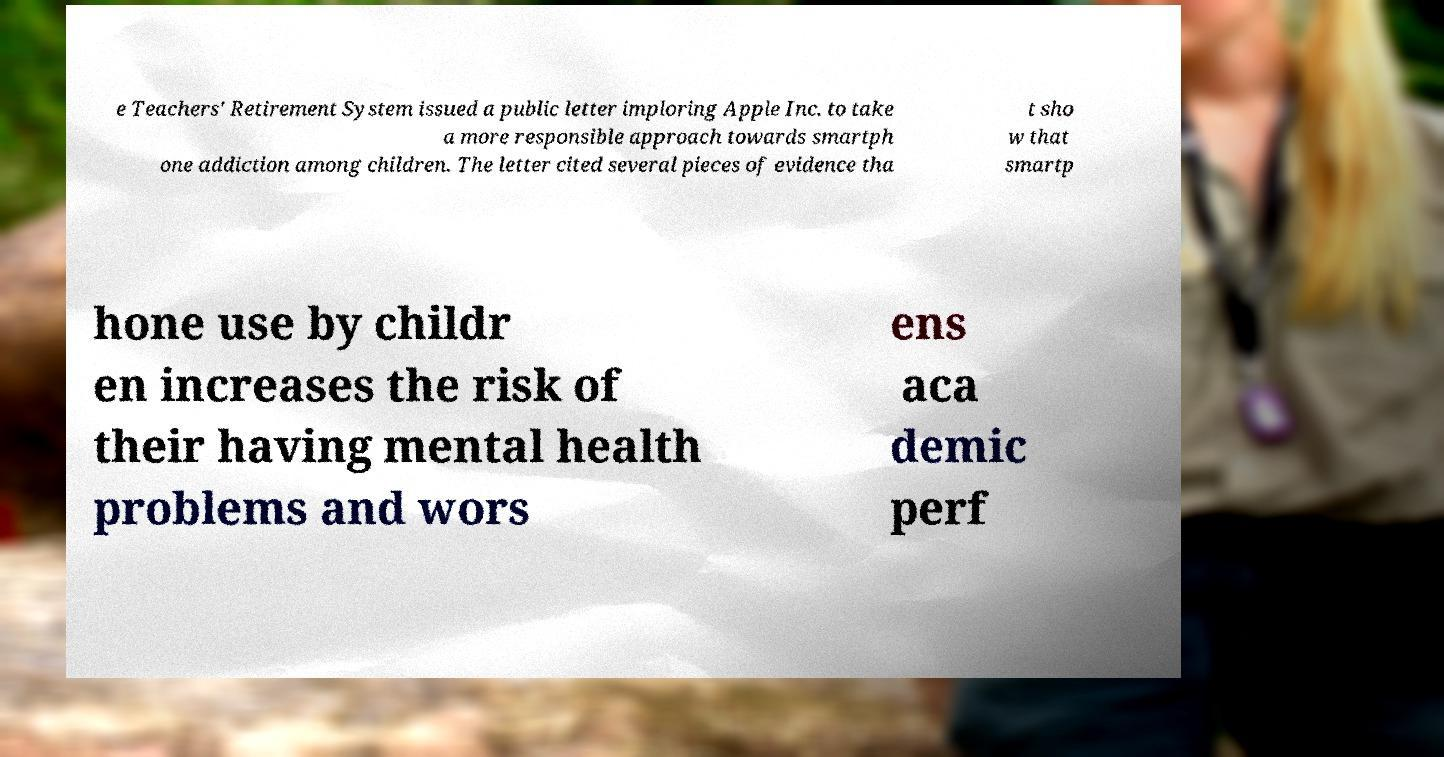What messages or text are displayed in this image? I need them in a readable, typed format. e Teachers' Retirement System issued a public letter imploring Apple Inc. to take a more responsible approach towards smartph one addiction among children. The letter cited several pieces of evidence tha t sho w that smartp hone use by childr en increases the risk of their having mental health problems and wors ens aca demic perf 